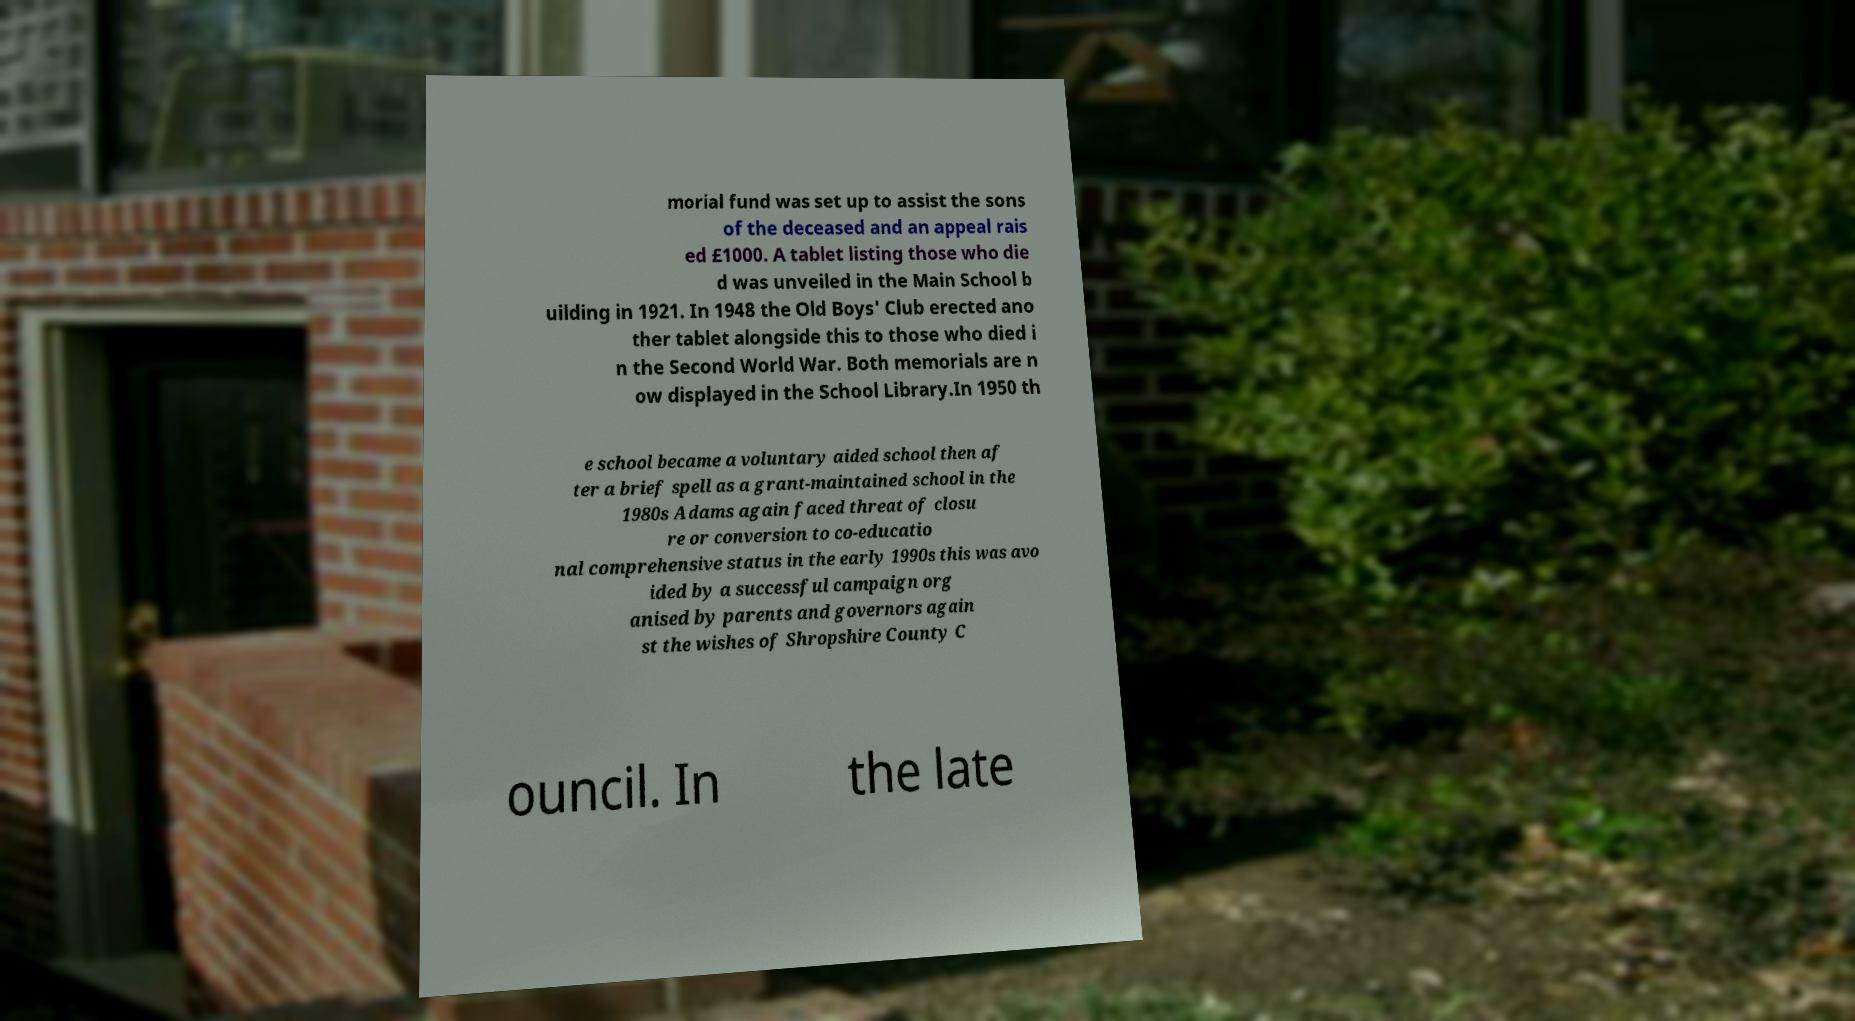What messages or text are displayed in this image? I need them in a readable, typed format. morial fund was set up to assist the sons of the deceased and an appeal rais ed £1000. A tablet listing those who die d was unveiled in the Main School b uilding in 1921. In 1948 the Old Boys' Club erected ano ther tablet alongside this to those who died i n the Second World War. Both memorials are n ow displayed in the School Library.In 1950 th e school became a voluntary aided school then af ter a brief spell as a grant-maintained school in the 1980s Adams again faced threat of closu re or conversion to co-educatio nal comprehensive status in the early 1990s this was avo ided by a successful campaign org anised by parents and governors again st the wishes of Shropshire County C ouncil. In the late 